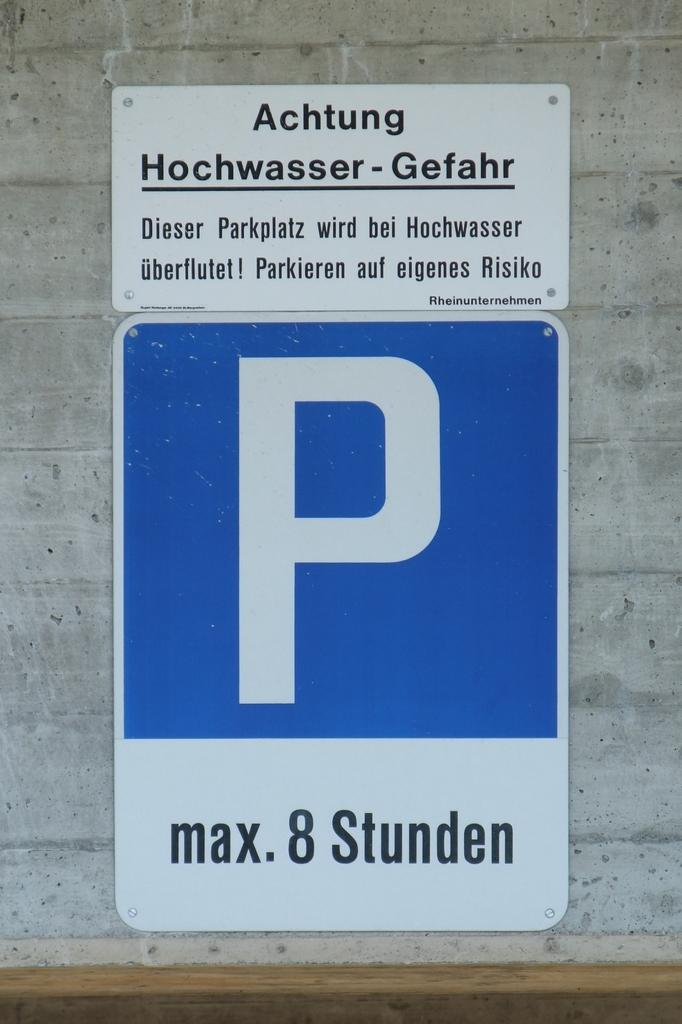<image>
Describe the image concisely. A blue and white parking sign with max. 8 Stunden on it. 